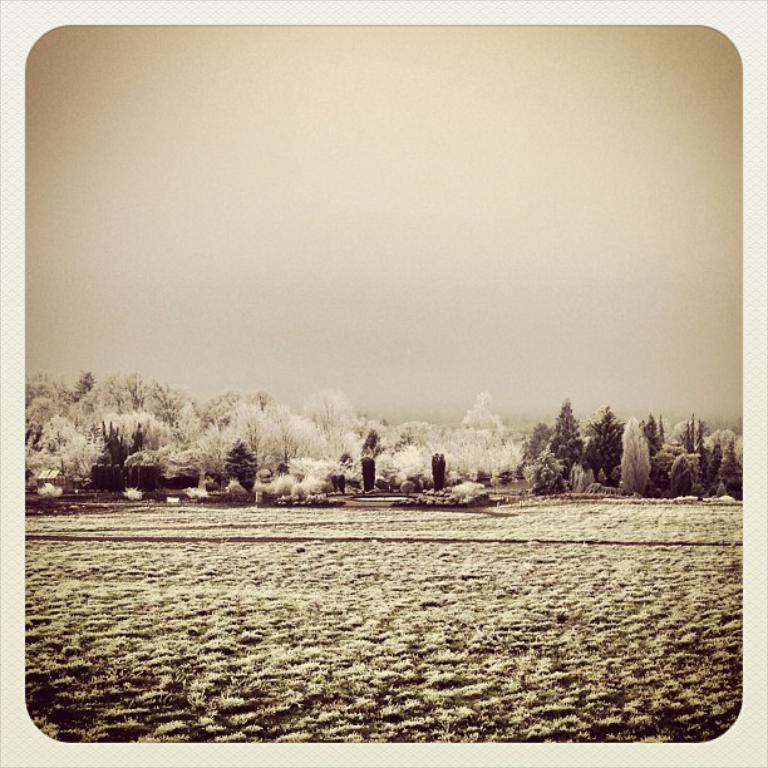Can you describe this image briefly? This is an edited image. At the bottom, I can see the grass on the ground. In the middle of the image there are plants and trees. At the top, I can see the sky. 